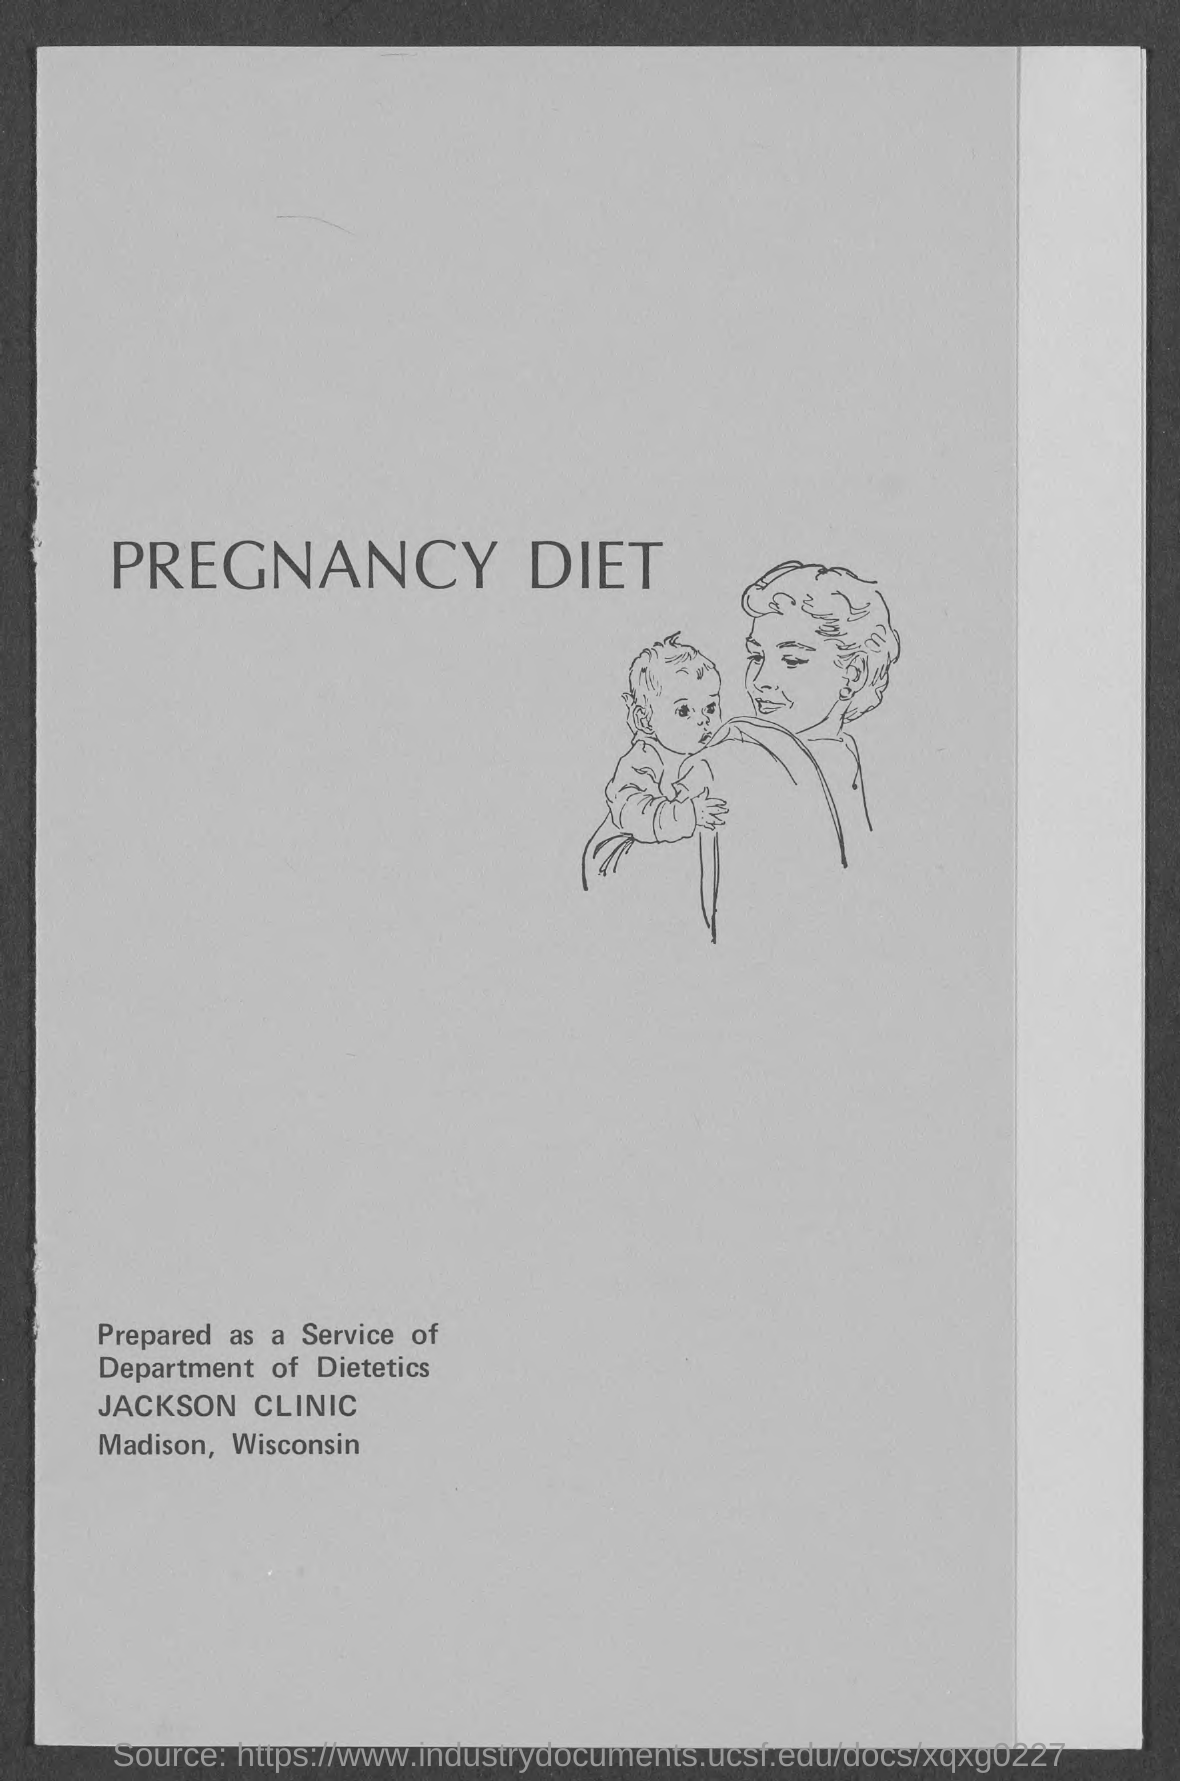What is title of the diet?
Provide a short and direct response. Pregnancy diet. 